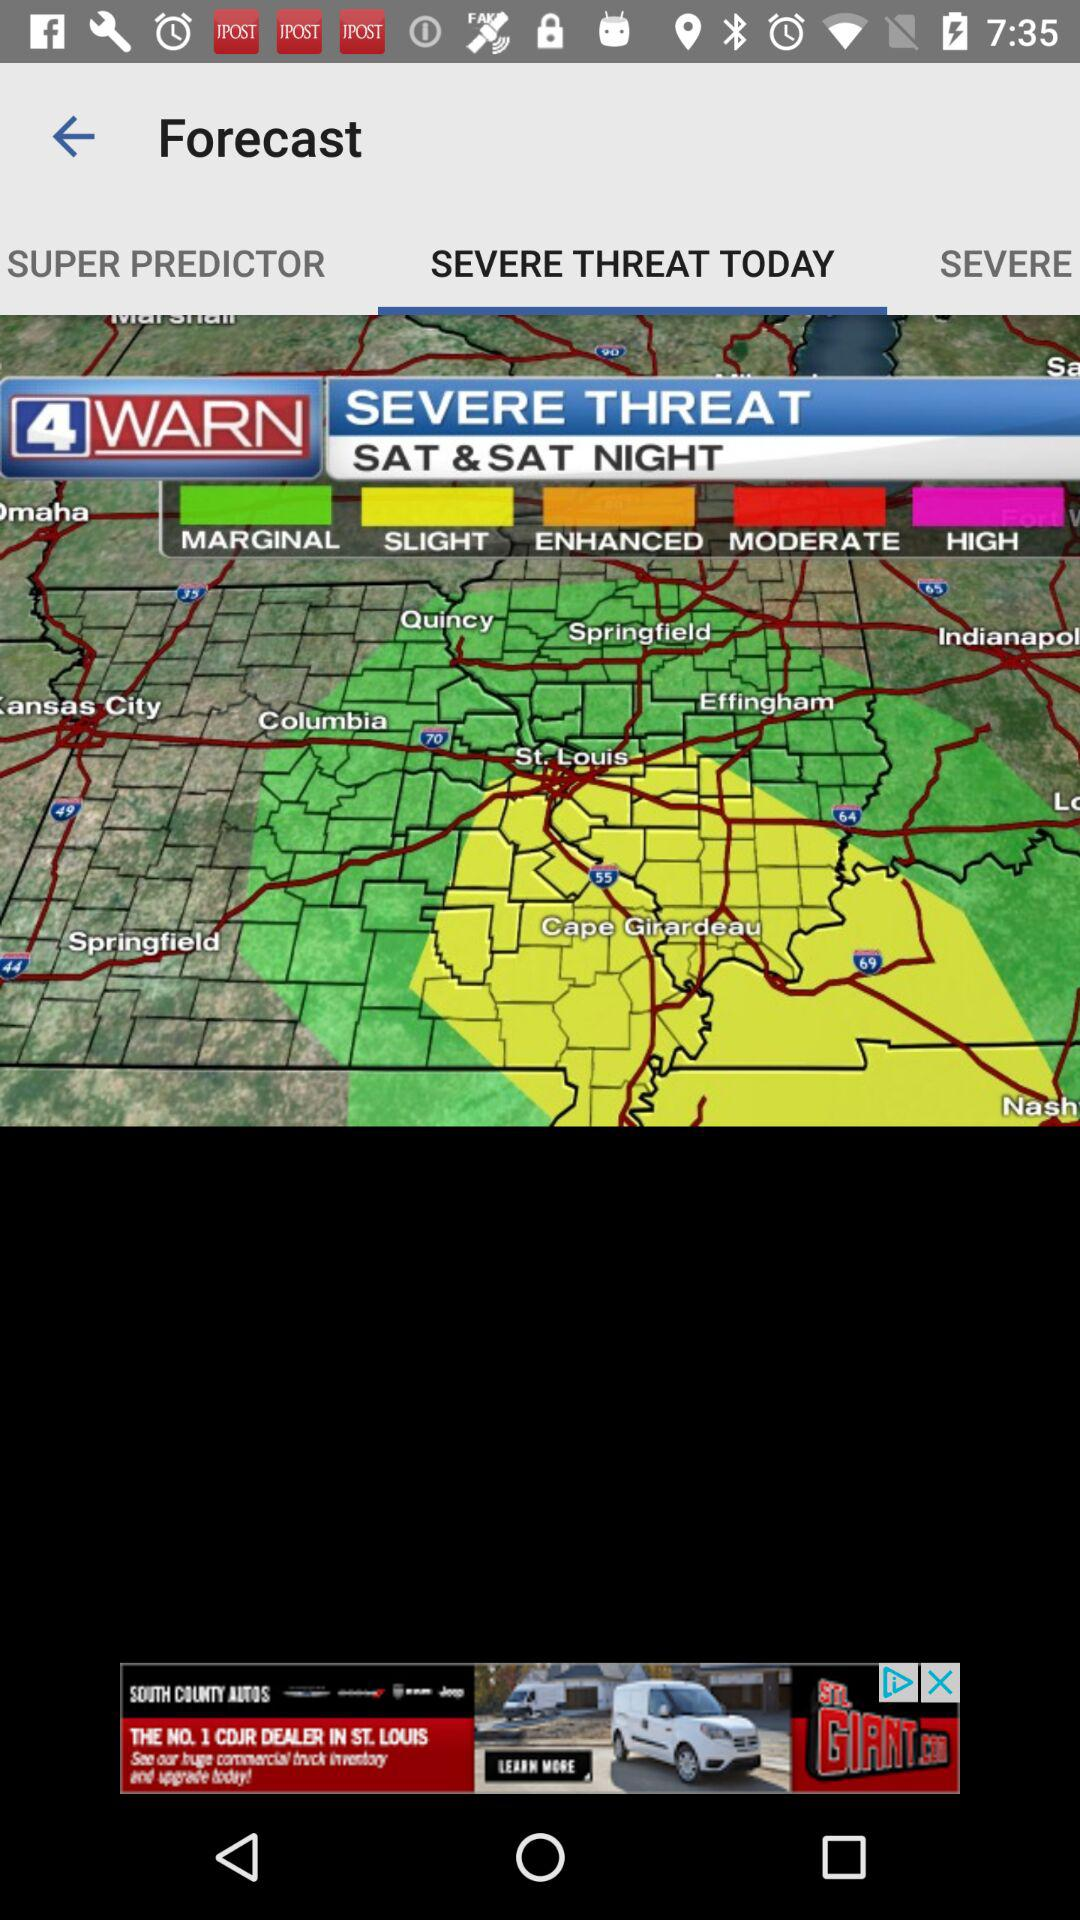Which tab am I using? The tab is "SEVERE THREAT TODAY". 